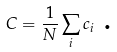Convert formula to latex. <formula><loc_0><loc_0><loc_500><loc_500>C = \frac { 1 } { N } \sum _ { i } c _ { i } \text { .}</formula> 